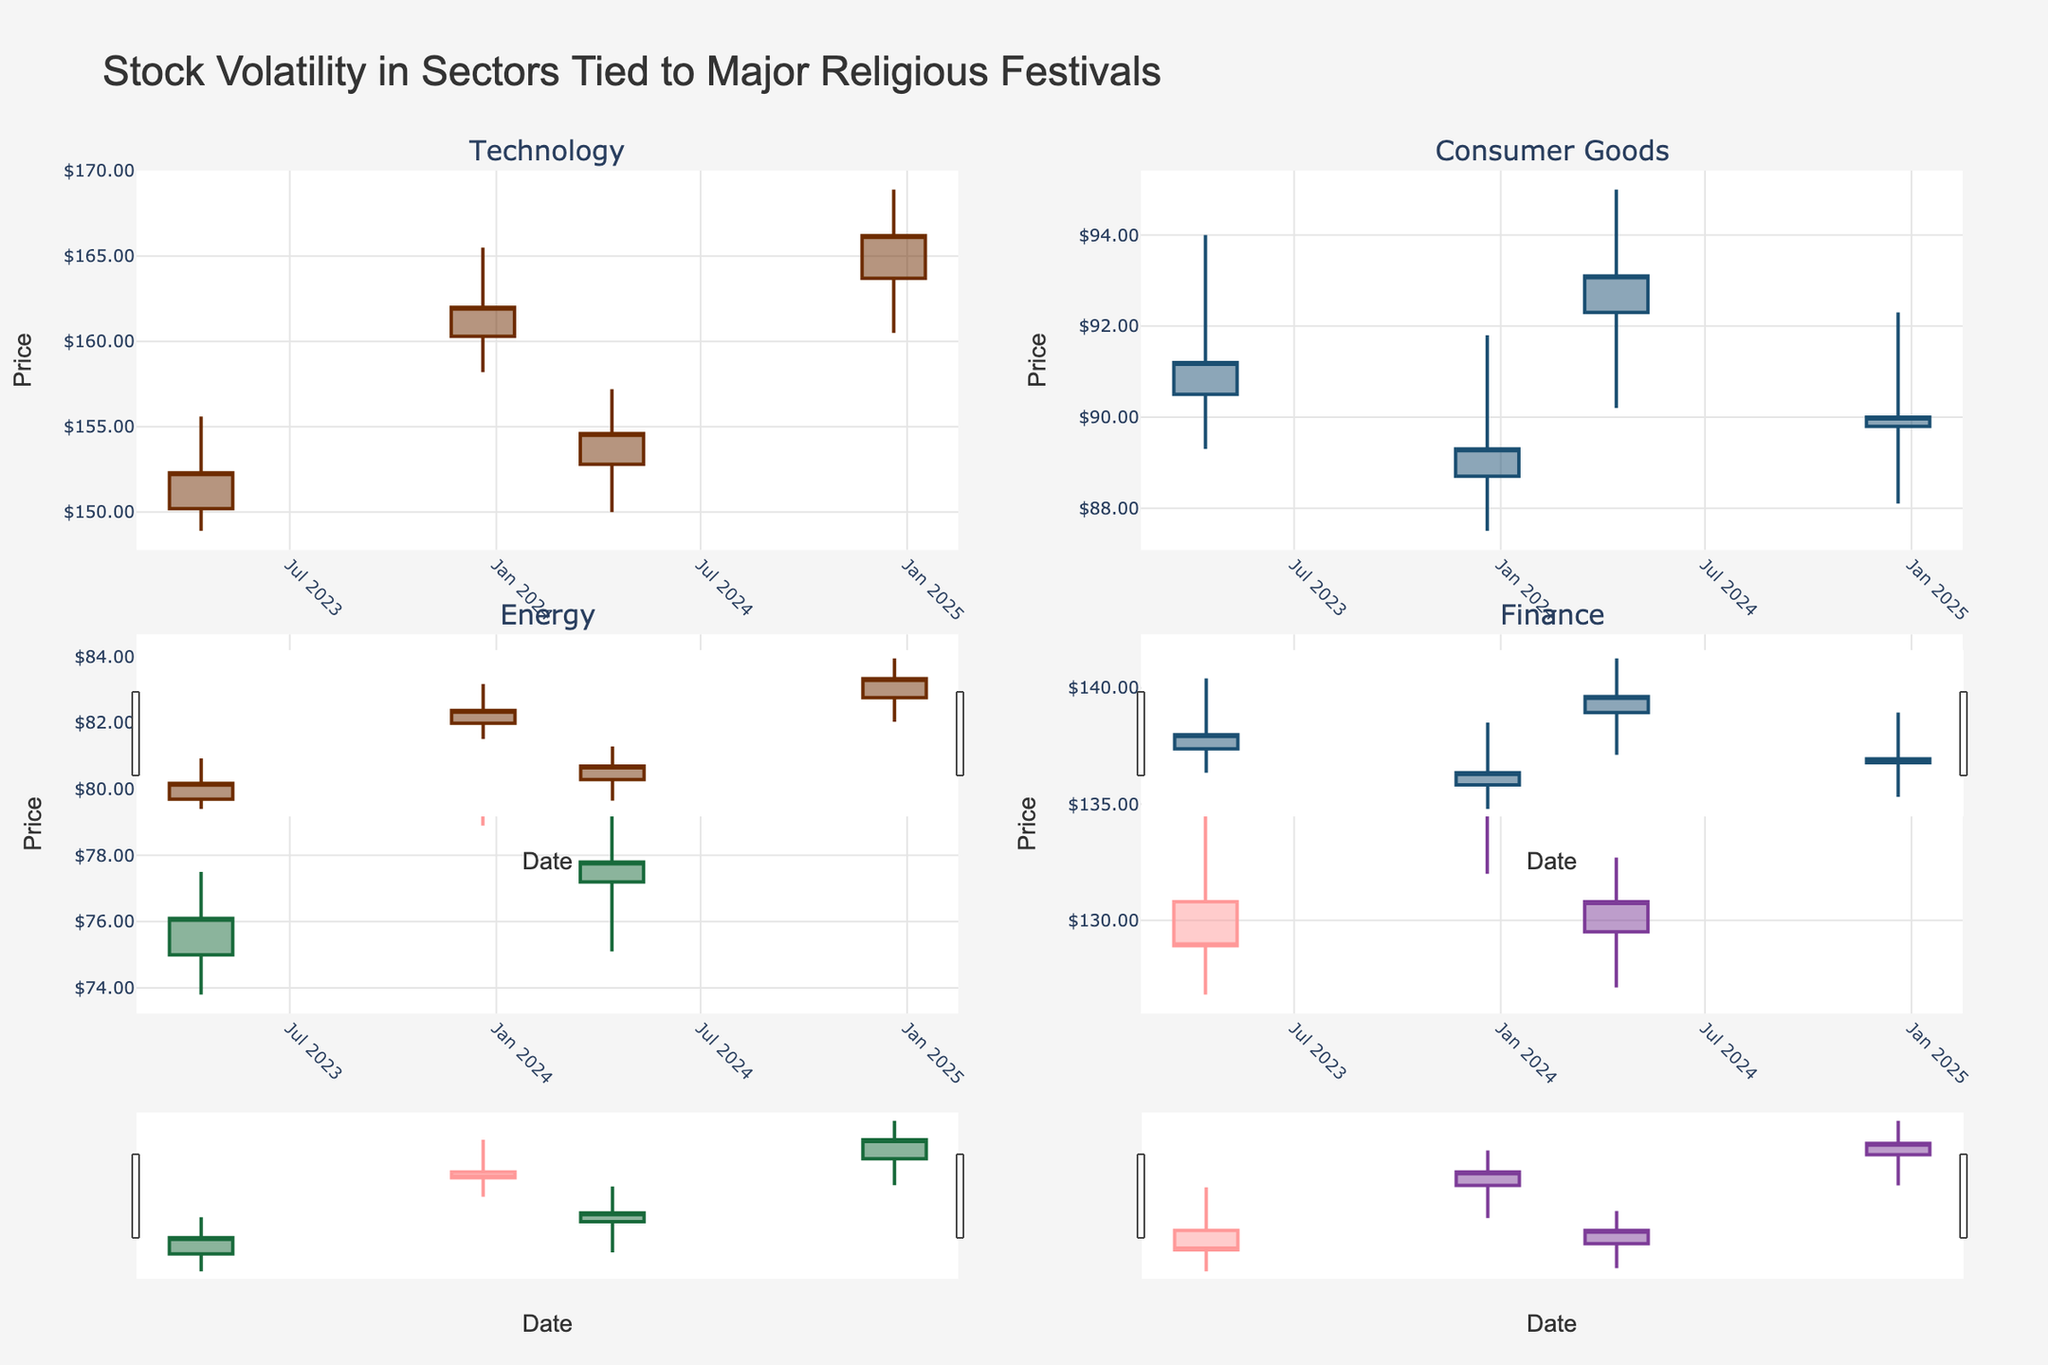What's the title of the figure? The title is located at the top of the figure, in larger and bold text. It succinctly describes the main theme of the dataset.
Answer: Stock Volatility in Sectors Tied to Major Religious Festivals How many sectors are depicted in the figure? The subplot titles list the sectors being analyzed. By counting these titles, we can determine the number of sectors.
Answer: 4 Which sector experienced the highest price on December 20, 2024? By examining the candlestick plots for each sector on December 20, 2024, we can identify the sector with the highest recorded price.
Answer: Technology What is the range of the closing prices for the Technology sector on the provided dates? Check the closing prices at each candlestick in the Technology sector's subplot and calculate the range (difference between highest and lowest closing prices).
Answer: $166.20 - $152.30 = $13.90 Was the closing price of the Finance sector higher or lower on April 13, 2024, compared to April 13, 2023? Compare the closing prices from the candlesticks corresponding to these dates in the Finance sector's subplot. Determine if the 2024 value is higher or lower than the 2023 value.
Answer: Higher Which sector had the smallest price range on December 20, 2023? For each sector, calculate the difference between the high and low prices on December 20, 2023. Identify the sector with the smallest range.
Answer: Consumer Goods Did the Energy sector experience a price increase or decrease from the open to close on December 20, 2024? Check the candlestick representing December 20, 2024, for the Energy sector to see if the closing price is higher or lower than the opening price.
Answer: Increase How does the volatility (price range) of the Consumer Goods sector compare between April 13, 2023, and April 13, 2024? For each date, calculate the range (difference between high and low prices) in the Consumer Goods sector. Compare these values to determine which date had higher volatility.
Answer: Higher on April 13, 2024 Which date had the highest closing price overall, across all sectors? Review the closing prices for all sectors on each date and identify the highest one among them.
Answer: December 20, 2024 